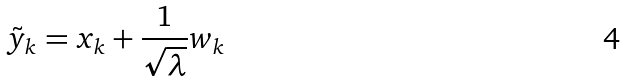Convert formula to latex. <formula><loc_0><loc_0><loc_500><loc_500>\tilde { y } _ { k } = x _ { k } + \frac { 1 } { \sqrt { \lambda } } w _ { k }</formula> 